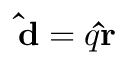<formula> <loc_0><loc_0><loc_500><loc_500>\hat { d } = q \hat { r }</formula> 